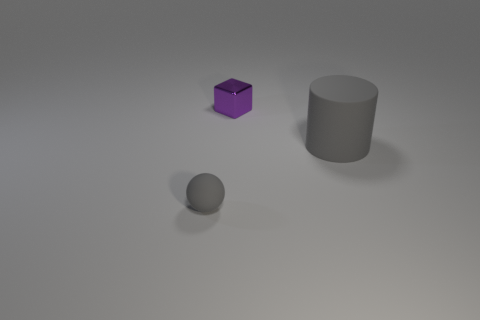There is a gray rubber thing that is behind the tiny gray ball; is it the same size as the object that is in front of the large gray rubber object?
Offer a terse response. No. What number of objects are either small objects that are in front of the big gray thing or things to the right of the tiny purple block?
Your answer should be compact. 2. Is there any other thing that is the same shape as the purple thing?
Your response must be concise. No. There is a object on the right side of the small purple cube; is it the same color as the rubber object that is to the left of the big rubber object?
Ensure brevity in your answer.  Yes. What number of metallic things are either small spheres or gray objects?
Ensure brevity in your answer.  0. Are there any other things that are the same size as the purple block?
Make the answer very short. Yes. There is a thing right of the small thing that is behind the large gray matte thing; what is its shape?
Your answer should be very brief. Cylinder. Is the tiny thing that is on the right side of the small gray sphere made of the same material as the small object that is to the left of the cube?
Offer a terse response. No. There is a small object in front of the metal object; how many metallic objects are behind it?
Give a very brief answer. 1. There is a gray rubber object in front of the matte cylinder; is it the same shape as the matte object that is on the right side of the small gray thing?
Ensure brevity in your answer.  No. 